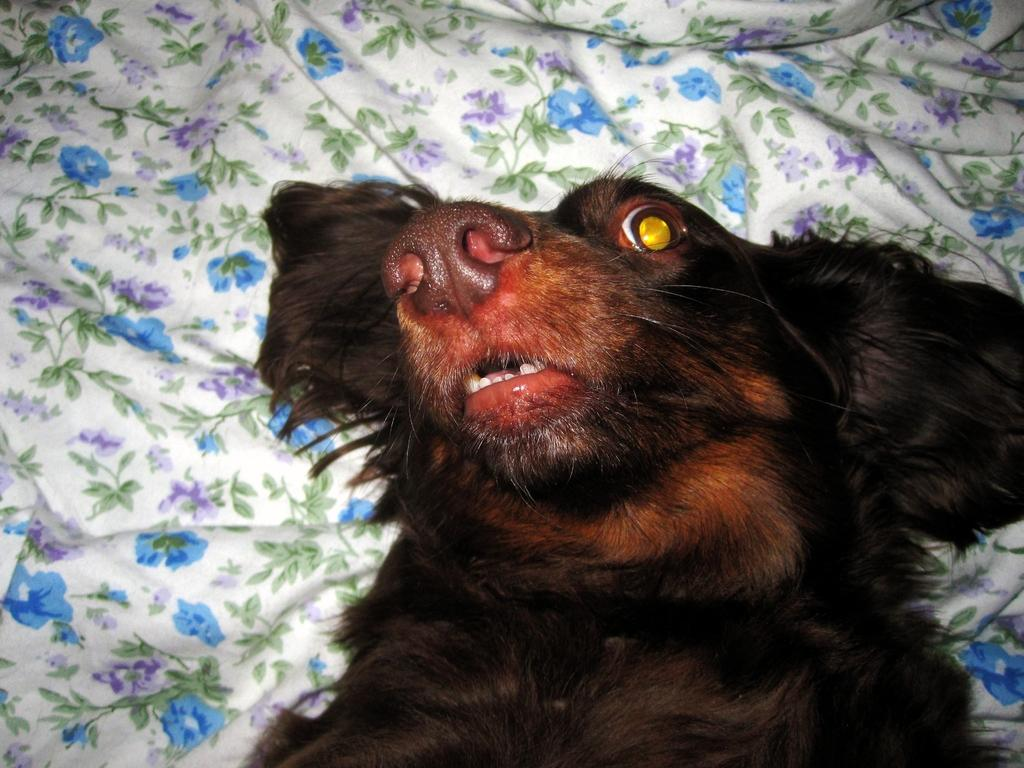What type of animal is present in the image? There is a dog in the image. What is the dog lying on? The dog is lying on a cloth. Can you describe the design of the cloth? The cloth has designs of flowers and leaves. What is the uncle's face like in the image? There is no uncle present in the image, so it is not possible to describe the uncle's face. 